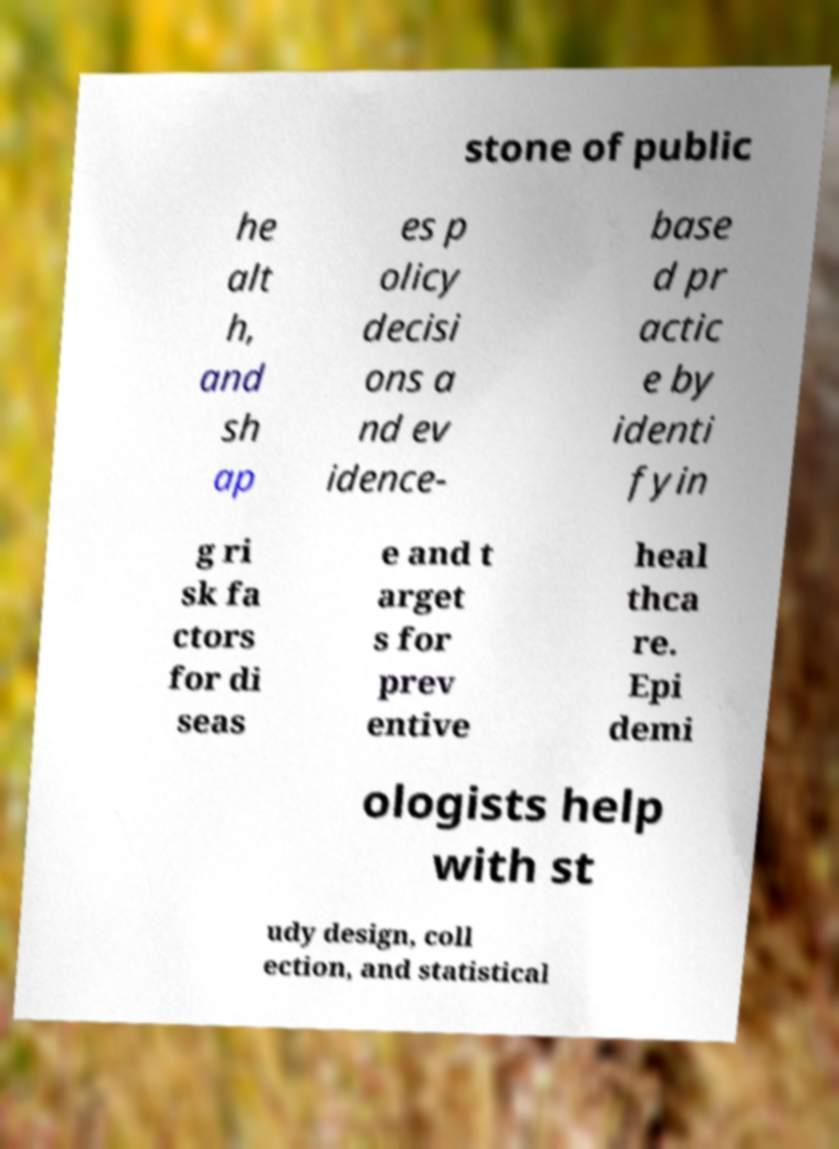Could you assist in decoding the text presented in this image and type it out clearly? stone of public he alt h, and sh ap es p olicy decisi ons a nd ev idence- base d pr actic e by identi fyin g ri sk fa ctors for di seas e and t arget s for prev entive heal thca re. Epi demi ologists help with st udy design, coll ection, and statistical 